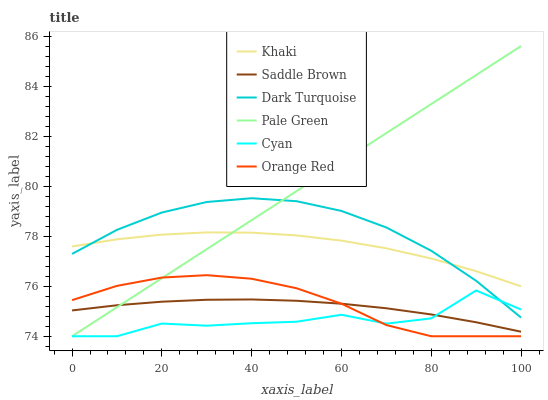Does Cyan have the minimum area under the curve?
Answer yes or no. Yes. Does Pale Green have the maximum area under the curve?
Answer yes or no. Yes. Does Dark Turquoise have the minimum area under the curve?
Answer yes or no. No. Does Dark Turquoise have the maximum area under the curve?
Answer yes or no. No. Is Pale Green the smoothest?
Answer yes or no. Yes. Is Cyan the roughest?
Answer yes or no. Yes. Is Dark Turquoise the smoothest?
Answer yes or no. No. Is Dark Turquoise the roughest?
Answer yes or no. No. Does Orange Red have the lowest value?
Answer yes or no. Yes. Does Dark Turquoise have the lowest value?
Answer yes or no. No. Does Pale Green have the highest value?
Answer yes or no. Yes. Does Dark Turquoise have the highest value?
Answer yes or no. No. Is Cyan less than Khaki?
Answer yes or no. Yes. Is Khaki greater than Cyan?
Answer yes or no. Yes. Does Cyan intersect Pale Green?
Answer yes or no. Yes. Is Cyan less than Pale Green?
Answer yes or no. No. Is Cyan greater than Pale Green?
Answer yes or no. No. Does Cyan intersect Khaki?
Answer yes or no. No. 